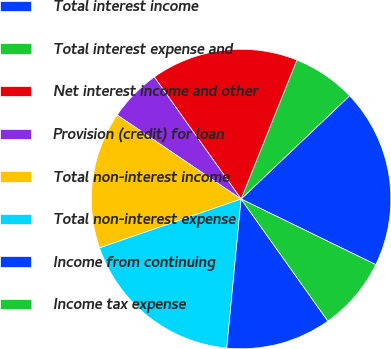<chart> <loc_0><loc_0><loc_500><loc_500><pie_chart><fcel>Total interest income<fcel>Total interest expense and<fcel>Net interest income and other<fcel>Provision (credit) for loan<fcel>Total non-interest income<fcel>Total non-interest expense<fcel>Income from continuing<fcel>Income tax expense<nl><fcel>19.32%<fcel>6.82%<fcel>15.91%<fcel>5.68%<fcel>14.77%<fcel>18.18%<fcel>11.36%<fcel>7.95%<nl></chart> 